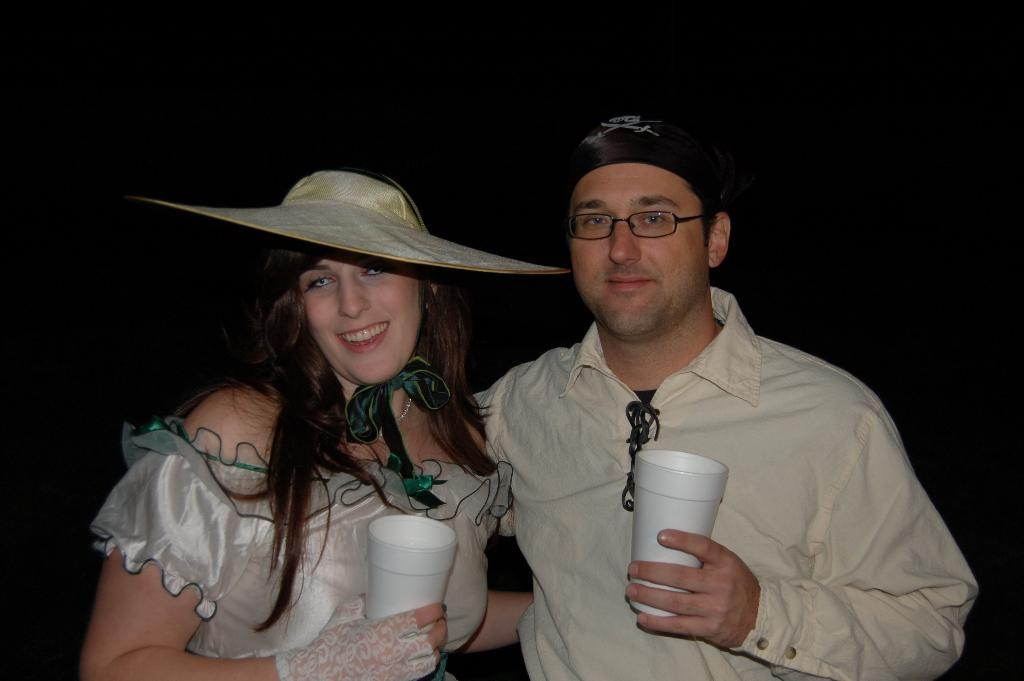How many people are in the image? There are two people in the image. What are the people holding in their hands? The people are holding glasses in their hands. What is the facial expression of the people in the image? The people are smiling. What can be observed about the background of the image? The background of the image is dark. What type of substance is being hammered by the person in the image? There is no person using a hammer in the image, nor is there any substance being hammered. 